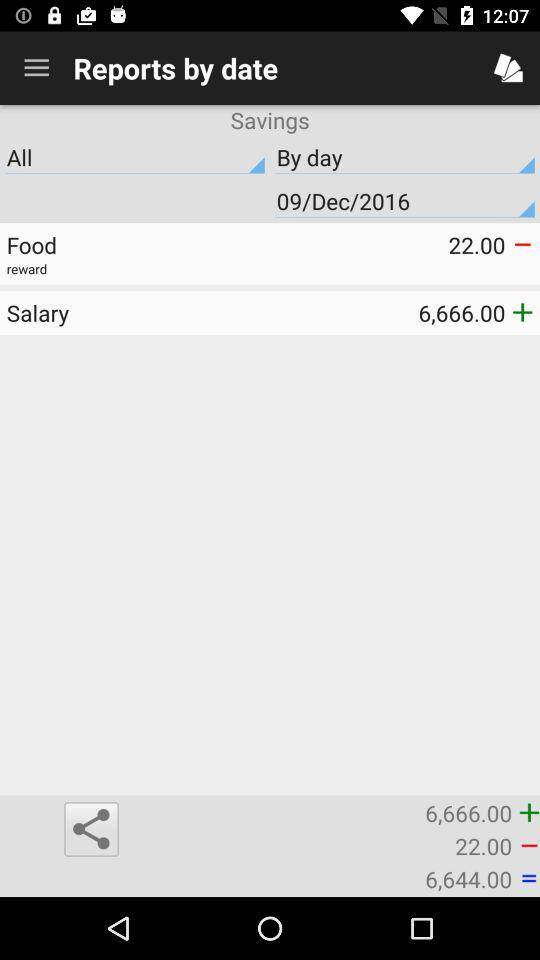What date is shown? The shown date is December 9, 2016. 